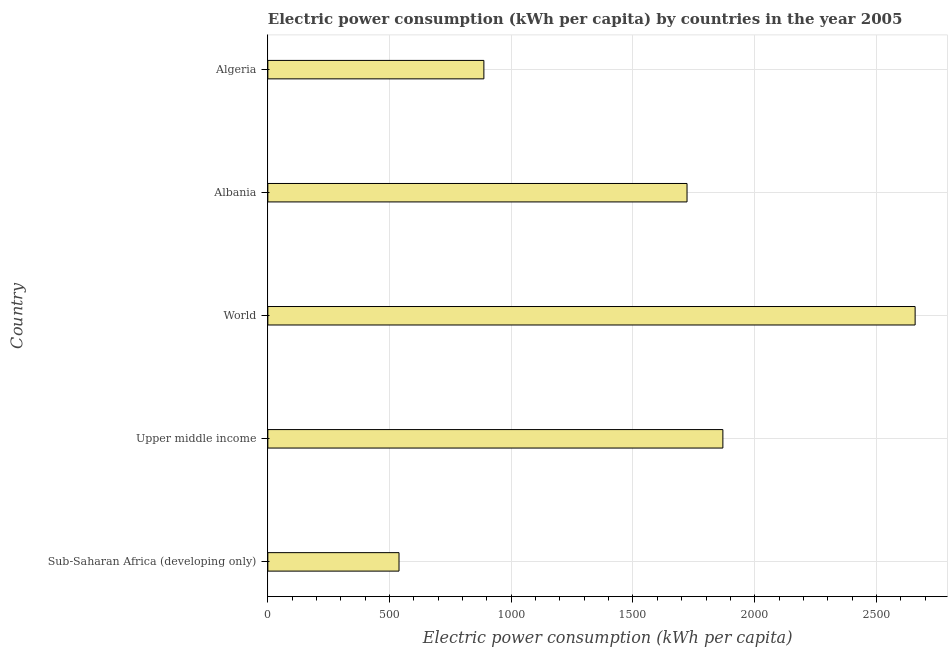Does the graph contain any zero values?
Keep it short and to the point. No. What is the title of the graph?
Keep it short and to the point. Electric power consumption (kWh per capita) by countries in the year 2005. What is the label or title of the X-axis?
Keep it short and to the point. Electric power consumption (kWh per capita). What is the electric power consumption in World?
Provide a short and direct response. 2659.1. Across all countries, what is the maximum electric power consumption?
Offer a terse response. 2659.1. Across all countries, what is the minimum electric power consumption?
Make the answer very short. 538.89. In which country was the electric power consumption minimum?
Provide a succinct answer. Sub-Saharan Africa (developing only). What is the sum of the electric power consumption?
Offer a very short reply. 7676.86. What is the difference between the electric power consumption in Albania and Sub-Saharan Africa (developing only)?
Offer a very short reply. 1183.18. What is the average electric power consumption per country?
Your answer should be very brief. 1535.37. What is the median electric power consumption?
Make the answer very short. 1722.07. In how many countries, is the electric power consumption greater than 2200 kWh per capita?
Your answer should be compact. 1. What is the ratio of the electric power consumption in Algeria to that in Upper middle income?
Offer a very short reply. 0.47. What is the difference between the highest and the second highest electric power consumption?
Provide a succinct answer. 789.78. Is the sum of the electric power consumption in Algeria and Sub-Saharan Africa (developing only) greater than the maximum electric power consumption across all countries?
Your response must be concise. No. What is the difference between the highest and the lowest electric power consumption?
Keep it short and to the point. 2120.21. In how many countries, is the electric power consumption greater than the average electric power consumption taken over all countries?
Provide a succinct answer. 3. Are all the bars in the graph horizontal?
Offer a very short reply. Yes. What is the difference between two consecutive major ticks on the X-axis?
Make the answer very short. 500. What is the Electric power consumption (kWh per capita) of Sub-Saharan Africa (developing only)?
Your answer should be compact. 538.89. What is the Electric power consumption (kWh per capita) of Upper middle income?
Provide a short and direct response. 1869.32. What is the Electric power consumption (kWh per capita) of World?
Offer a very short reply. 2659.1. What is the Electric power consumption (kWh per capita) in Albania?
Make the answer very short. 1722.07. What is the Electric power consumption (kWh per capita) of Algeria?
Your response must be concise. 887.46. What is the difference between the Electric power consumption (kWh per capita) in Sub-Saharan Africa (developing only) and Upper middle income?
Offer a very short reply. -1330.43. What is the difference between the Electric power consumption (kWh per capita) in Sub-Saharan Africa (developing only) and World?
Provide a succinct answer. -2120.21. What is the difference between the Electric power consumption (kWh per capita) in Sub-Saharan Africa (developing only) and Albania?
Provide a succinct answer. -1183.18. What is the difference between the Electric power consumption (kWh per capita) in Sub-Saharan Africa (developing only) and Algeria?
Your answer should be compact. -348.57. What is the difference between the Electric power consumption (kWh per capita) in Upper middle income and World?
Your response must be concise. -789.78. What is the difference between the Electric power consumption (kWh per capita) in Upper middle income and Albania?
Offer a very short reply. 147.25. What is the difference between the Electric power consumption (kWh per capita) in Upper middle income and Algeria?
Provide a succinct answer. 981.86. What is the difference between the Electric power consumption (kWh per capita) in World and Albania?
Offer a terse response. 937.03. What is the difference between the Electric power consumption (kWh per capita) in World and Algeria?
Give a very brief answer. 1771.64. What is the difference between the Electric power consumption (kWh per capita) in Albania and Algeria?
Your answer should be very brief. 834.61. What is the ratio of the Electric power consumption (kWh per capita) in Sub-Saharan Africa (developing only) to that in Upper middle income?
Your answer should be compact. 0.29. What is the ratio of the Electric power consumption (kWh per capita) in Sub-Saharan Africa (developing only) to that in World?
Provide a short and direct response. 0.2. What is the ratio of the Electric power consumption (kWh per capita) in Sub-Saharan Africa (developing only) to that in Albania?
Provide a succinct answer. 0.31. What is the ratio of the Electric power consumption (kWh per capita) in Sub-Saharan Africa (developing only) to that in Algeria?
Provide a short and direct response. 0.61. What is the ratio of the Electric power consumption (kWh per capita) in Upper middle income to that in World?
Keep it short and to the point. 0.7. What is the ratio of the Electric power consumption (kWh per capita) in Upper middle income to that in Albania?
Offer a very short reply. 1.09. What is the ratio of the Electric power consumption (kWh per capita) in Upper middle income to that in Algeria?
Ensure brevity in your answer.  2.11. What is the ratio of the Electric power consumption (kWh per capita) in World to that in Albania?
Your answer should be very brief. 1.54. What is the ratio of the Electric power consumption (kWh per capita) in World to that in Algeria?
Offer a terse response. 3. What is the ratio of the Electric power consumption (kWh per capita) in Albania to that in Algeria?
Make the answer very short. 1.94. 